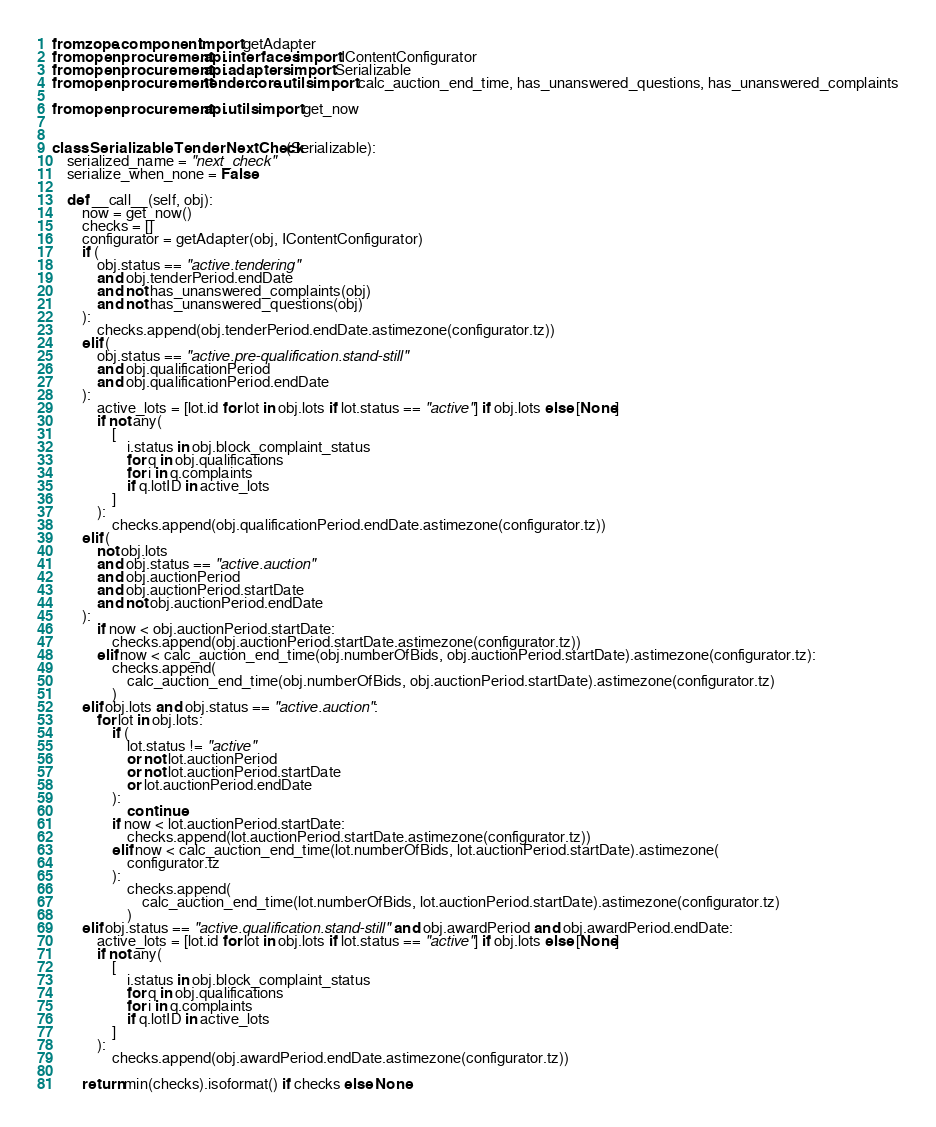<code> <loc_0><loc_0><loc_500><loc_500><_Python_>from zope.component import getAdapter
from openprocurement.api.interfaces import IContentConfigurator
from openprocurement.api.adapters import Serializable
from openprocurement.tender.core.utils import calc_auction_end_time, has_unanswered_questions, has_unanswered_complaints

from openprocurement.api.utils import get_now


class SerializableTenderNextCheck(Serializable):
    serialized_name = "next_check"
    serialize_when_none = False

    def __call__(self, obj):
        now = get_now()
        checks = []
        configurator = getAdapter(obj, IContentConfigurator)
        if (
            obj.status == "active.tendering"
            and obj.tenderPeriod.endDate
            and not has_unanswered_complaints(obj)
            and not has_unanswered_questions(obj)
        ):
            checks.append(obj.tenderPeriod.endDate.astimezone(configurator.tz))
        elif (
            obj.status == "active.pre-qualification.stand-still"
            and obj.qualificationPeriod
            and obj.qualificationPeriod.endDate
        ):
            active_lots = [lot.id for lot in obj.lots if lot.status == "active"] if obj.lots else [None]
            if not any(
                [
                    i.status in obj.block_complaint_status
                    for q in obj.qualifications
                    for i in q.complaints
                    if q.lotID in active_lots
                ]
            ):
                checks.append(obj.qualificationPeriod.endDate.astimezone(configurator.tz))
        elif (
            not obj.lots
            and obj.status == "active.auction"
            and obj.auctionPeriod
            and obj.auctionPeriod.startDate
            and not obj.auctionPeriod.endDate
        ):
            if now < obj.auctionPeriod.startDate:
                checks.append(obj.auctionPeriod.startDate.astimezone(configurator.tz))
            elif now < calc_auction_end_time(obj.numberOfBids, obj.auctionPeriod.startDate).astimezone(configurator.tz):
                checks.append(
                    calc_auction_end_time(obj.numberOfBids, obj.auctionPeriod.startDate).astimezone(configurator.tz)
                )
        elif obj.lots and obj.status == "active.auction":
            for lot in obj.lots:
                if (
                    lot.status != "active"
                    or not lot.auctionPeriod
                    or not lot.auctionPeriod.startDate
                    or lot.auctionPeriod.endDate
                ):
                    continue
                if now < lot.auctionPeriod.startDate:
                    checks.append(lot.auctionPeriod.startDate.astimezone(configurator.tz))
                elif now < calc_auction_end_time(lot.numberOfBids, lot.auctionPeriod.startDate).astimezone(
                    configurator.tz
                ):
                    checks.append(
                        calc_auction_end_time(lot.numberOfBids, lot.auctionPeriod.startDate).astimezone(configurator.tz)
                    )
        elif obj.status == "active.qualification.stand-still" and obj.awardPeriod and obj.awardPeriod.endDate:
            active_lots = [lot.id for lot in obj.lots if lot.status == "active"] if obj.lots else [None]
            if not any(
                [
                    i.status in obj.block_complaint_status
                    for q in obj.qualifications
                    for i in q.complaints
                    if q.lotID in active_lots
                ]
            ):
                checks.append(obj.awardPeriod.endDate.astimezone(configurator.tz))

        return min(checks).isoformat() if checks else None
</code> 